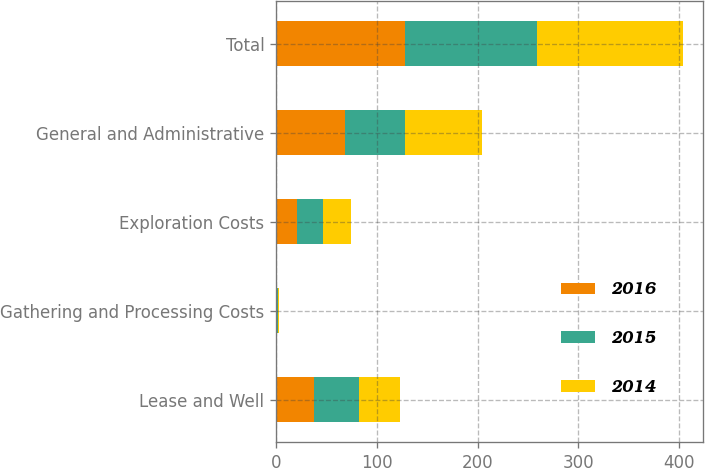Convert chart. <chart><loc_0><loc_0><loc_500><loc_500><stacked_bar_chart><ecel><fcel>Lease and Well<fcel>Gathering and Processing Costs<fcel>Exploration Costs<fcel>General and Administrative<fcel>Total<nl><fcel>2016<fcel>38<fcel>1<fcel>21<fcel>68<fcel>128<nl><fcel>2015<fcel>44<fcel>1<fcel>26<fcel>60<fcel>131<nl><fcel>2014<fcel>41<fcel>1<fcel>27<fcel>76<fcel>145<nl></chart> 